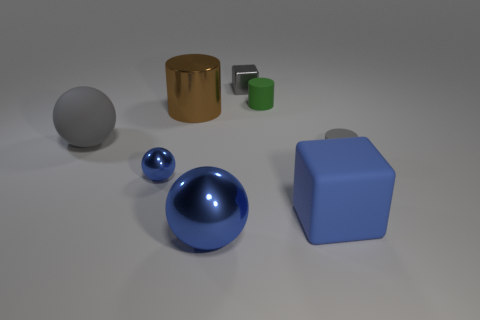Subtract all gray balls. How many balls are left? 2 Subtract all tiny shiny balls. How many balls are left? 2 Subtract 1 green cylinders. How many objects are left? 7 Subtract all cylinders. How many objects are left? 5 Subtract 3 spheres. How many spheres are left? 0 Subtract all cyan spheres. Subtract all purple cylinders. How many spheres are left? 3 Subtract all red balls. How many brown cylinders are left? 1 Subtract all large gray shiny objects. Subtract all tiny gray rubber objects. How many objects are left? 7 Add 4 gray blocks. How many gray blocks are left? 5 Add 6 large objects. How many large objects exist? 10 